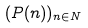<formula> <loc_0><loc_0><loc_500><loc_500>( P ( n ) ) _ { n \in N }</formula> 